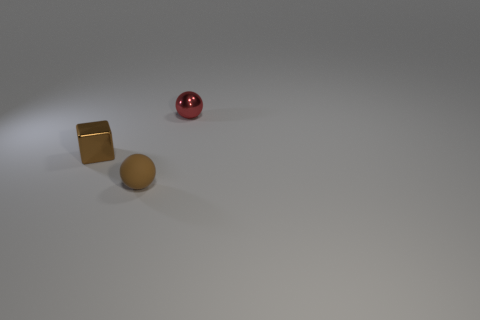If the sphere were to roll towards the nearest object, which object would it reach first? Assuming that the sphere would travel in a straight line from its current position, it would reach the gold-colored metallic block first, given that the block is closest to the sphere in this viewpoint. 